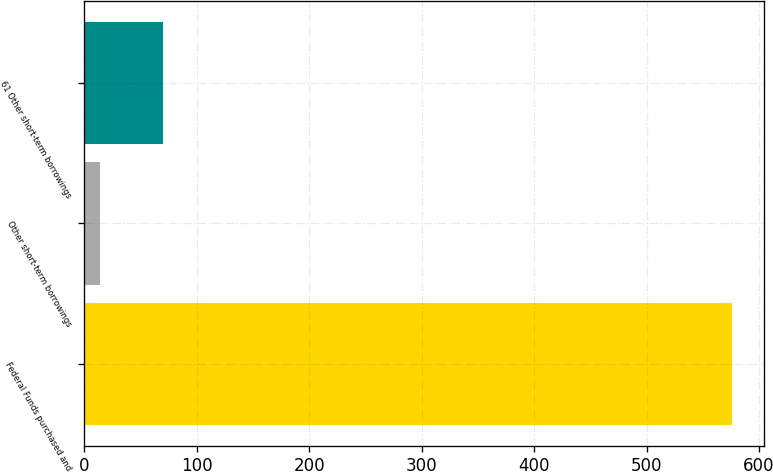Convert chart to OTSL. <chart><loc_0><loc_0><loc_500><loc_500><bar_chart><fcel>Federal Funds purchased and<fcel>Other short-term borrowings<fcel>61 Other short-term borrowings<nl><fcel>576<fcel>14<fcel>70.2<nl></chart> 